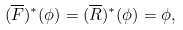<formula> <loc_0><loc_0><loc_500><loc_500>( \overline { F } ) ^ { * } ( \phi ) = ( \overline { R } ) ^ { * } ( \phi ) = \phi ,</formula> 